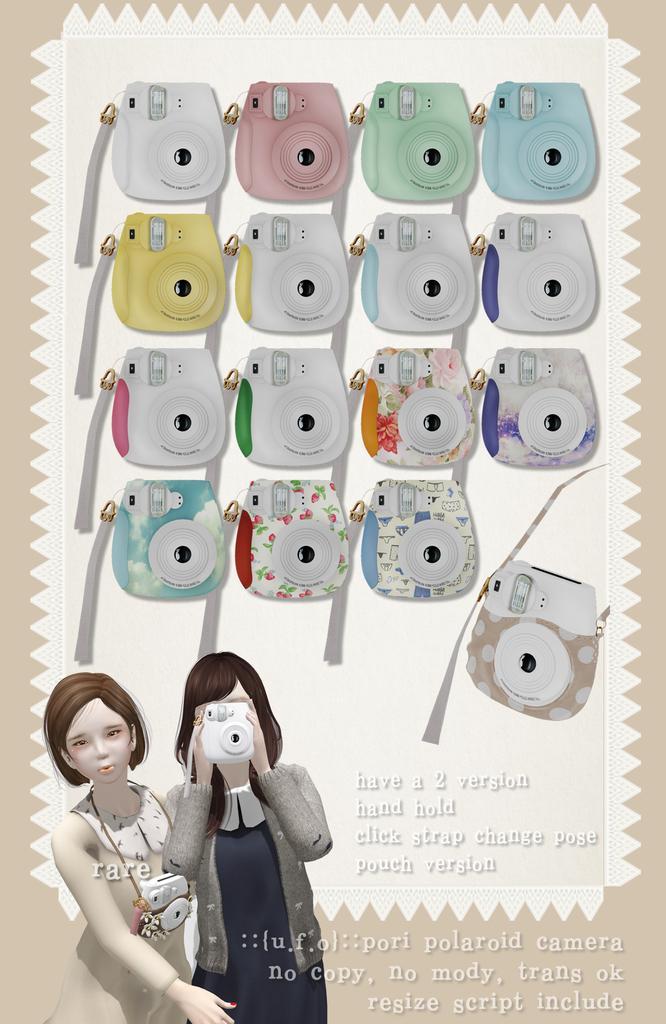Describe this image in one or two sentences. Here we can see camera with different colors and different patterns on it. On the left at the bottom corner we can see two cartoon women images where one is carrying a camera on her neck and the other is holding a camera in her hands and we can also see some text written on the right side of the image. 